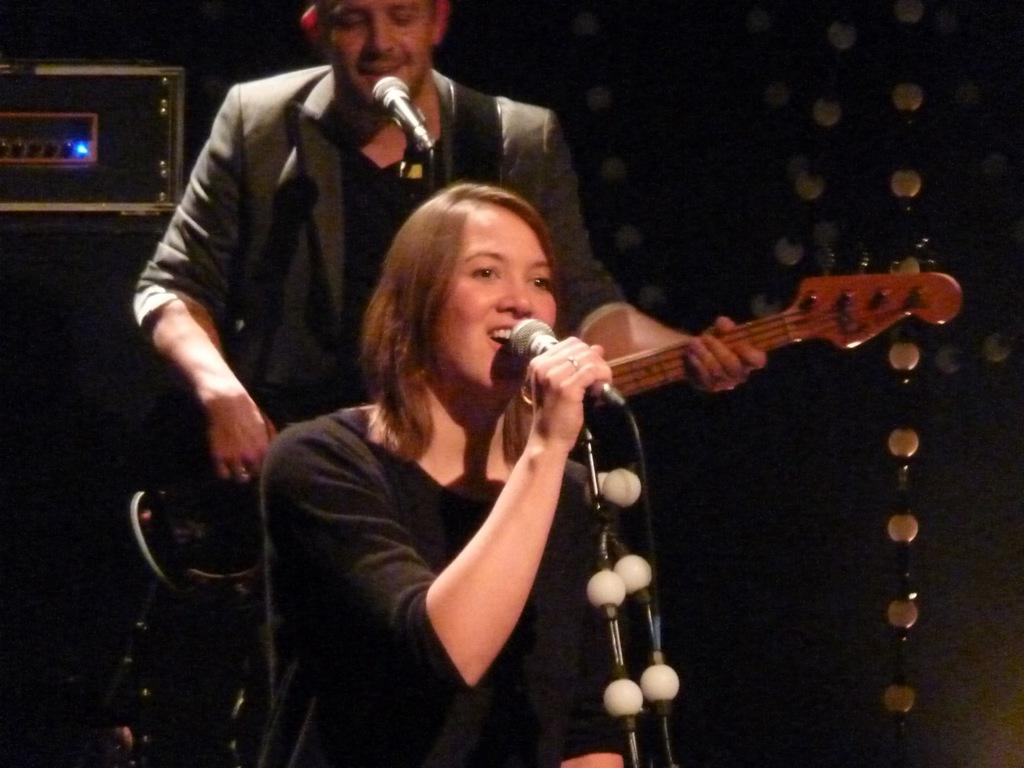What is the woman in the image doing? The woman is singing into a microphone. Who else is present in the image? There is a man in the image. What is the man doing? The man is also singing into a microphone and holding a guitar. Can you describe the man's position in relation to the woman? The man is standing behind the woman. What type of leather material can be seen on the wall in the image? There is no wall or leather material present in the image. 